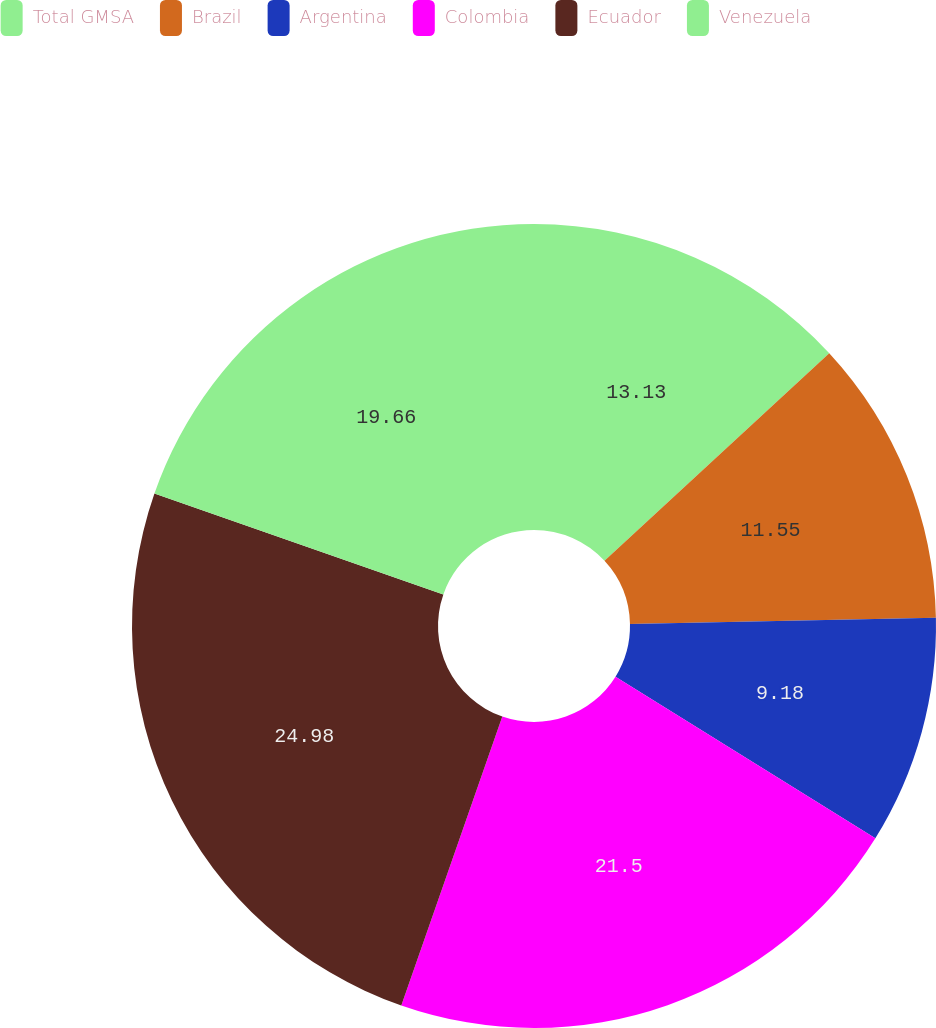Convert chart to OTSL. <chart><loc_0><loc_0><loc_500><loc_500><pie_chart><fcel>Total GMSA<fcel>Brazil<fcel>Argentina<fcel>Colombia<fcel>Ecuador<fcel>Venezuela<nl><fcel>13.13%<fcel>11.55%<fcel>9.18%<fcel>21.5%<fcel>24.99%<fcel>19.66%<nl></chart> 